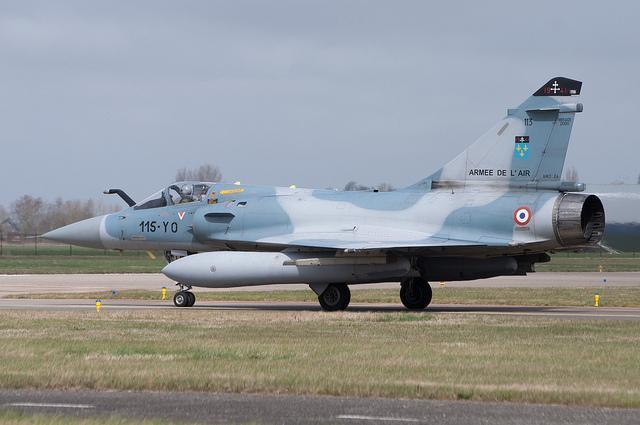What country does this plane belong to?
From the following four choices, select the correct answer to address the question.
Options: Uganda, france, poland, canada. France. 